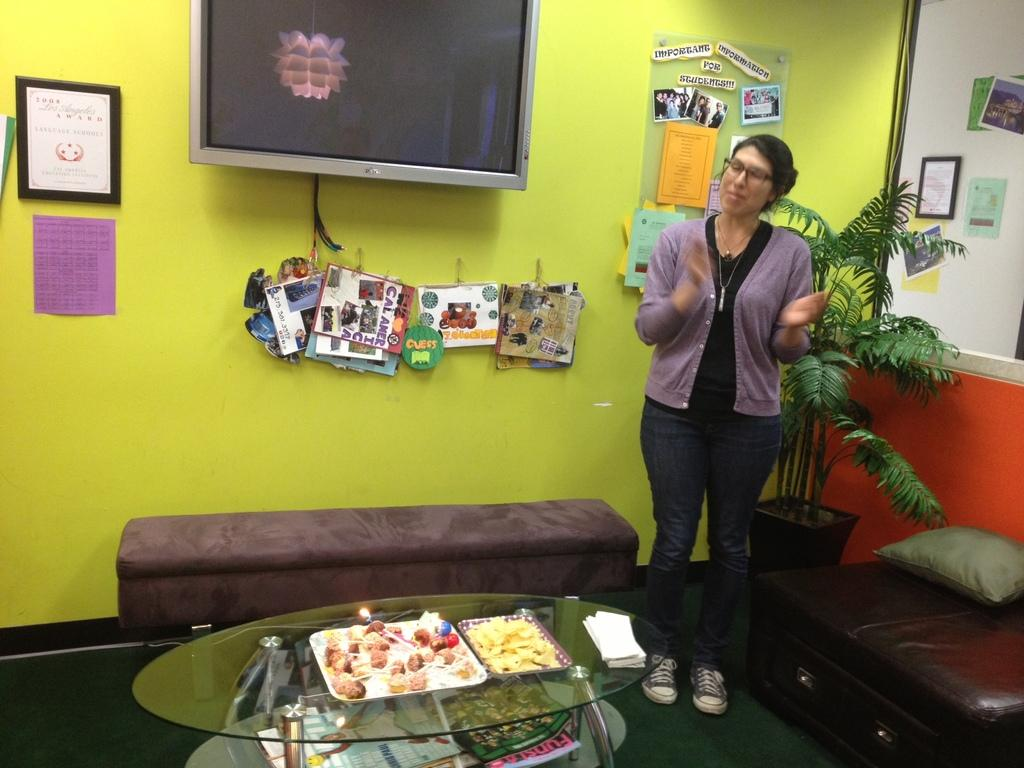What is the main subject of the image? There is a woman standing in the image. What else can be seen in the image besides the woman? There is a table in the image, as well as a TV on the wall. What is on the table in the image? Food items are present on the table in a tray. Are the woman's sisters camping with her in the image? There is no indication of sisters or camping in the image; it only shows a woman standing, a table with food items, and a TV on the wall. 